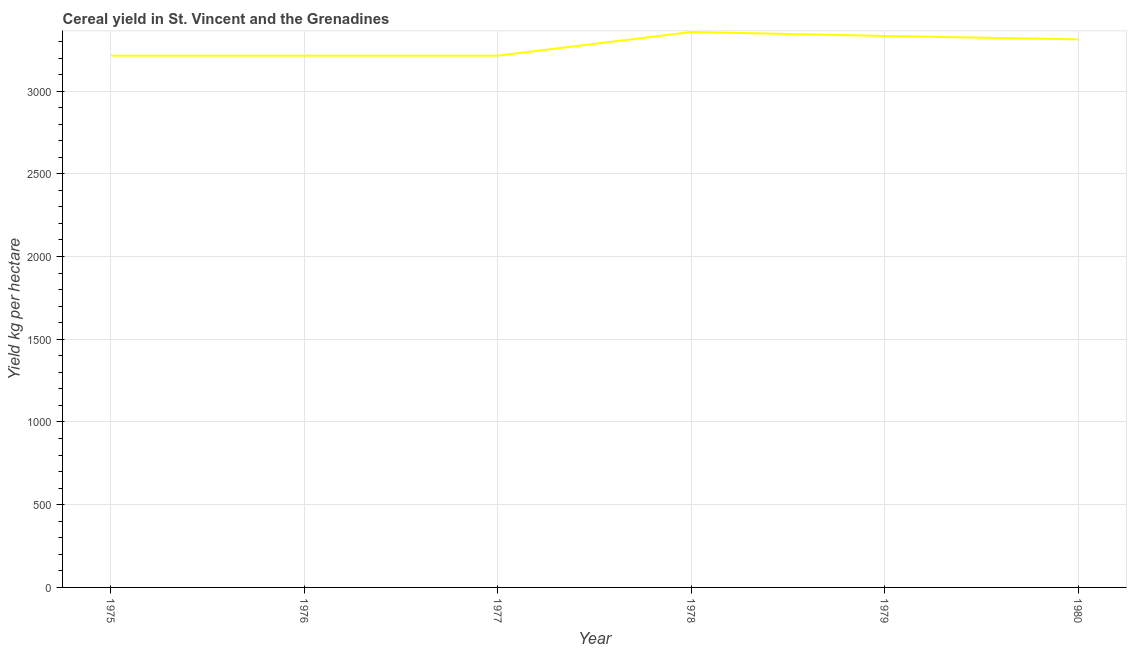What is the cereal yield in 1979?
Ensure brevity in your answer.  3333.33. Across all years, what is the maximum cereal yield?
Keep it short and to the point. 3357.14. Across all years, what is the minimum cereal yield?
Offer a terse response. 3214.29. In which year was the cereal yield maximum?
Provide a short and direct response. 1978. In which year was the cereal yield minimum?
Offer a terse response. 1975. What is the sum of the cereal yield?
Provide a succinct answer. 1.96e+04. What is the difference between the cereal yield in 1975 and 1978?
Offer a very short reply. -142.86. What is the average cereal yield per year?
Your answer should be compact. 3274.31. What is the median cereal yield?
Your response must be concise. 3263.39. What is the ratio of the cereal yield in 1977 to that in 1980?
Your answer should be compact. 0.97. Is the difference between the cereal yield in 1975 and 1980 greater than the difference between any two years?
Make the answer very short. No. What is the difference between the highest and the second highest cereal yield?
Your answer should be very brief. 23.81. Is the sum of the cereal yield in 1977 and 1979 greater than the maximum cereal yield across all years?
Your answer should be compact. Yes. What is the difference between the highest and the lowest cereal yield?
Offer a very short reply. 142.86. In how many years, is the cereal yield greater than the average cereal yield taken over all years?
Your answer should be compact. 3. Does the cereal yield monotonically increase over the years?
Your answer should be very brief. No. How many lines are there?
Give a very brief answer. 1. Are the values on the major ticks of Y-axis written in scientific E-notation?
Your answer should be compact. No. Does the graph contain any zero values?
Your answer should be very brief. No. What is the title of the graph?
Offer a terse response. Cereal yield in St. Vincent and the Grenadines. What is the label or title of the Y-axis?
Keep it short and to the point. Yield kg per hectare. What is the Yield kg per hectare of 1975?
Ensure brevity in your answer.  3214.29. What is the Yield kg per hectare in 1976?
Ensure brevity in your answer.  3214.29. What is the Yield kg per hectare of 1977?
Offer a terse response. 3214.29. What is the Yield kg per hectare in 1978?
Provide a short and direct response. 3357.14. What is the Yield kg per hectare of 1979?
Give a very brief answer. 3333.33. What is the Yield kg per hectare in 1980?
Your answer should be compact. 3312.5. What is the difference between the Yield kg per hectare in 1975 and 1977?
Keep it short and to the point. 0. What is the difference between the Yield kg per hectare in 1975 and 1978?
Give a very brief answer. -142.86. What is the difference between the Yield kg per hectare in 1975 and 1979?
Provide a succinct answer. -119.05. What is the difference between the Yield kg per hectare in 1975 and 1980?
Make the answer very short. -98.21. What is the difference between the Yield kg per hectare in 1976 and 1978?
Provide a short and direct response. -142.86. What is the difference between the Yield kg per hectare in 1976 and 1979?
Offer a very short reply. -119.05. What is the difference between the Yield kg per hectare in 1976 and 1980?
Your answer should be compact. -98.21. What is the difference between the Yield kg per hectare in 1977 and 1978?
Provide a succinct answer. -142.86. What is the difference between the Yield kg per hectare in 1977 and 1979?
Provide a succinct answer. -119.05. What is the difference between the Yield kg per hectare in 1977 and 1980?
Your answer should be compact. -98.21. What is the difference between the Yield kg per hectare in 1978 and 1979?
Make the answer very short. 23.81. What is the difference between the Yield kg per hectare in 1978 and 1980?
Ensure brevity in your answer.  44.64. What is the difference between the Yield kg per hectare in 1979 and 1980?
Give a very brief answer. 20.83. What is the ratio of the Yield kg per hectare in 1975 to that in 1976?
Ensure brevity in your answer.  1. What is the ratio of the Yield kg per hectare in 1975 to that in 1977?
Offer a very short reply. 1. What is the ratio of the Yield kg per hectare in 1975 to that in 1978?
Make the answer very short. 0.96. What is the ratio of the Yield kg per hectare in 1975 to that in 1980?
Give a very brief answer. 0.97. What is the ratio of the Yield kg per hectare in 1976 to that in 1979?
Give a very brief answer. 0.96. What is the ratio of the Yield kg per hectare in 1977 to that in 1978?
Offer a very short reply. 0.96. What is the ratio of the Yield kg per hectare in 1977 to that in 1979?
Your response must be concise. 0.96. What is the ratio of the Yield kg per hectare in 1978 to that in 1979?
Your response must be concise. 1.01. What is the ratio of the Yield kg per hectare in 1979 to that in 1980?
Provide a succinct answer. 1.01. 